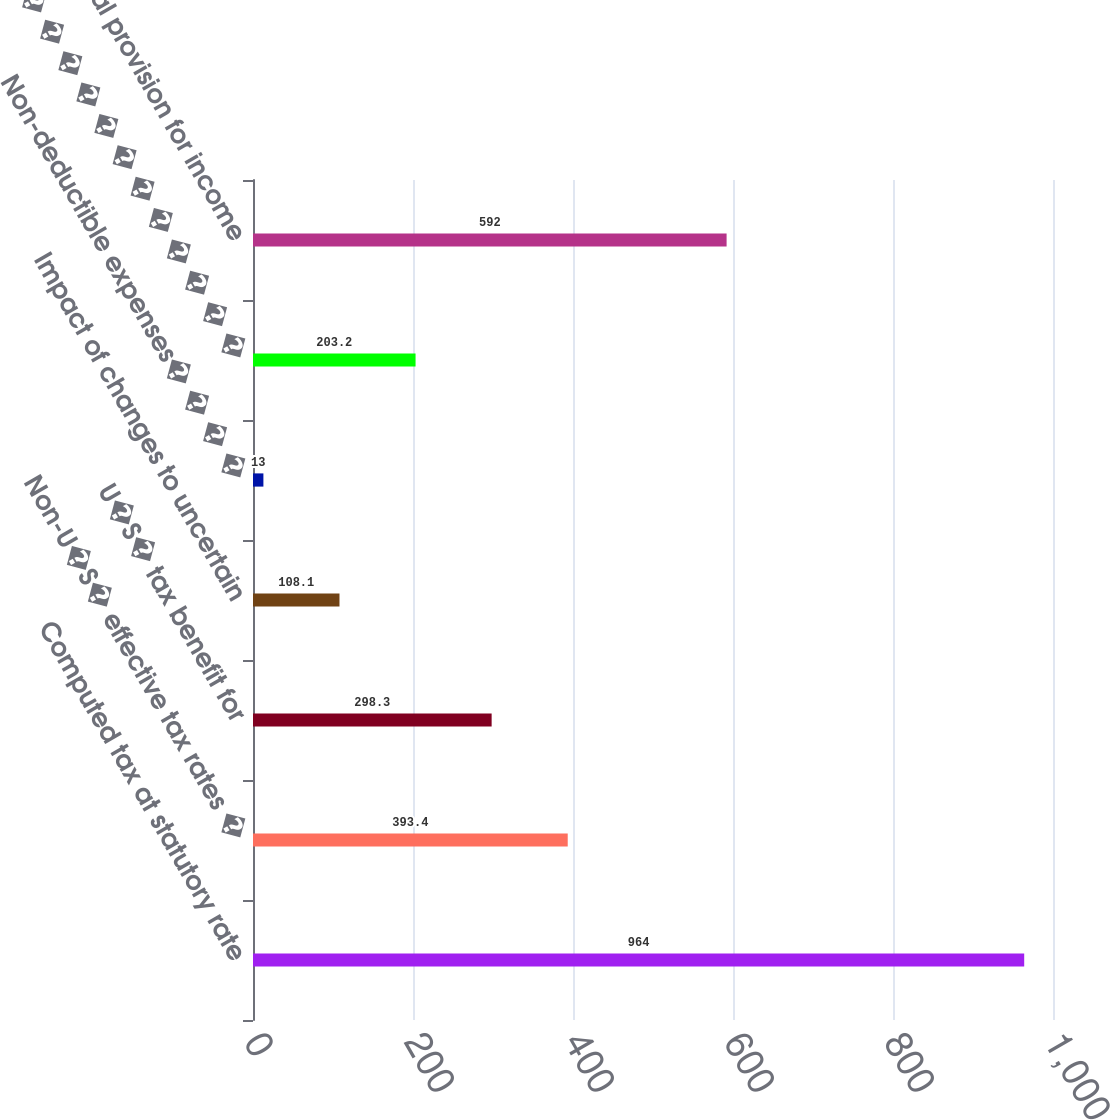Convert chart. <chart><loc_0><loc_0><loc_500><loc_500><bar_chart><fcel>Computed tax at statutory rate<fcel>Non-U�S� effective tax rates �<fcel>U�S� tax benefit for<fcel>Impact of changes to uncertain<fcel>Non-deductible expenses� � � �<fcel>Other � � � � � � � � � � � �<fcel>Total provision for income<nl><fcel>964<fcel>393.4<fcel>298.3<fcel>108.1<fcel>13<fcel>203.2<fcel>592<nl></chart> 